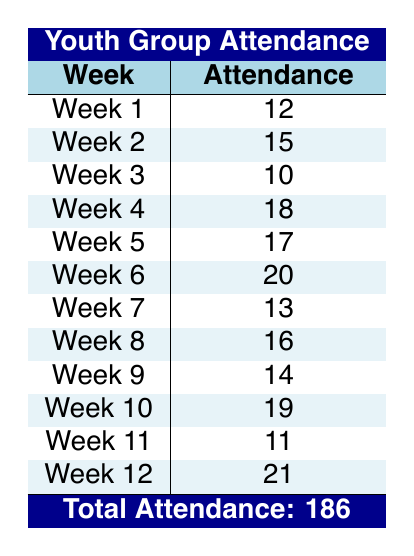What was the attendance in Week 5? From the table, we look at the row for Week 5, which indicates an attendance of 17.
Answer: 17 What was the highest attendance recorded during the semester? To find the highest attendance, we scan each row of the table for the largest number. Week 12 shows an attendance of 21, which is the maximum value.
Answer: 21 How many weeks had an attendance of 15 or more? We need to count the weeks where attendance was 15 or greater. By examining the table, we find that Weeks 2, 4, 5, 6, 10, and 12 all have attendance of 15 or more, totaling 6 weeks.
Answer: 6 What is the total attendance for the semester? The total attendance is given at the bottom of the table as 186, which represents the sum of all individual weekly attendances.
Answer: 186 Is it true that the attendance decreased in Week 3 compared to Week 2? We look at the attendance numbers for both weeks; Week 2 has 15 attendees while Week 3 has 10, which shows a decrease.
Answer: Yes What is the average attendance over the 12 weeks? To find the average, we sum the attendance numbers (186) and divide by 12 (the number of weeks). Therefore, 186 / 12 = 15.5.
Answer: 15.5 How many more attendees were present in Week 12 than in Week 1? By comparing the two weeks, Week 12 had 21 attendees and Week 1 had 12. The difference is 21 - 12 = 9.
Answer: 9 Which week's attendance was the lowest? Referring to the table, the lowest attendance is found in Week 3, where there were 10 attendees.
Answer: Week 3 What percentage of weeks had more than 15 attendees? There are 6 weeks with more than 15 attendees out of 12 total weeks. The percentage is (6/12) * 100, which equals 50%.
Answer: 50% 